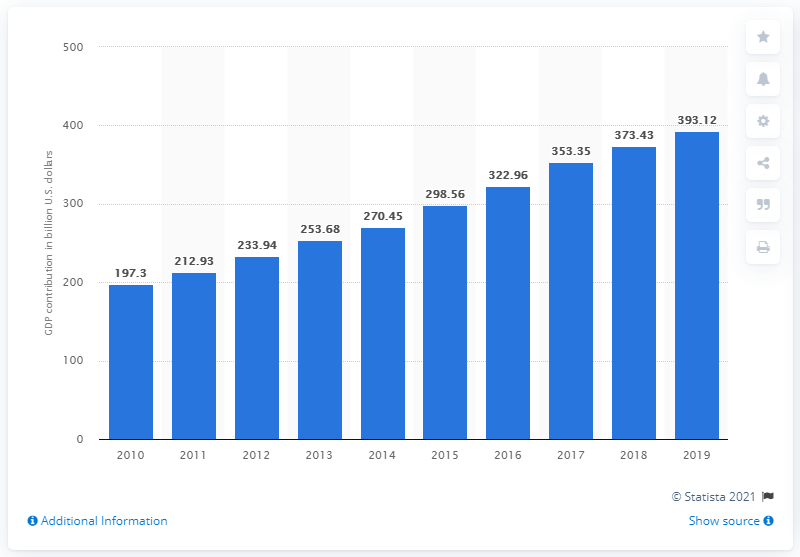Specify some key components in this picture. In 2019, the travel and tourism industry contributed a significant 393.12% to Southeast Asia's GDP. The travel and tourism industry contributed a significant amount to the Gross Domestic Product (GDP) of Southeast Asia in 2010, with a value of 197.3. 